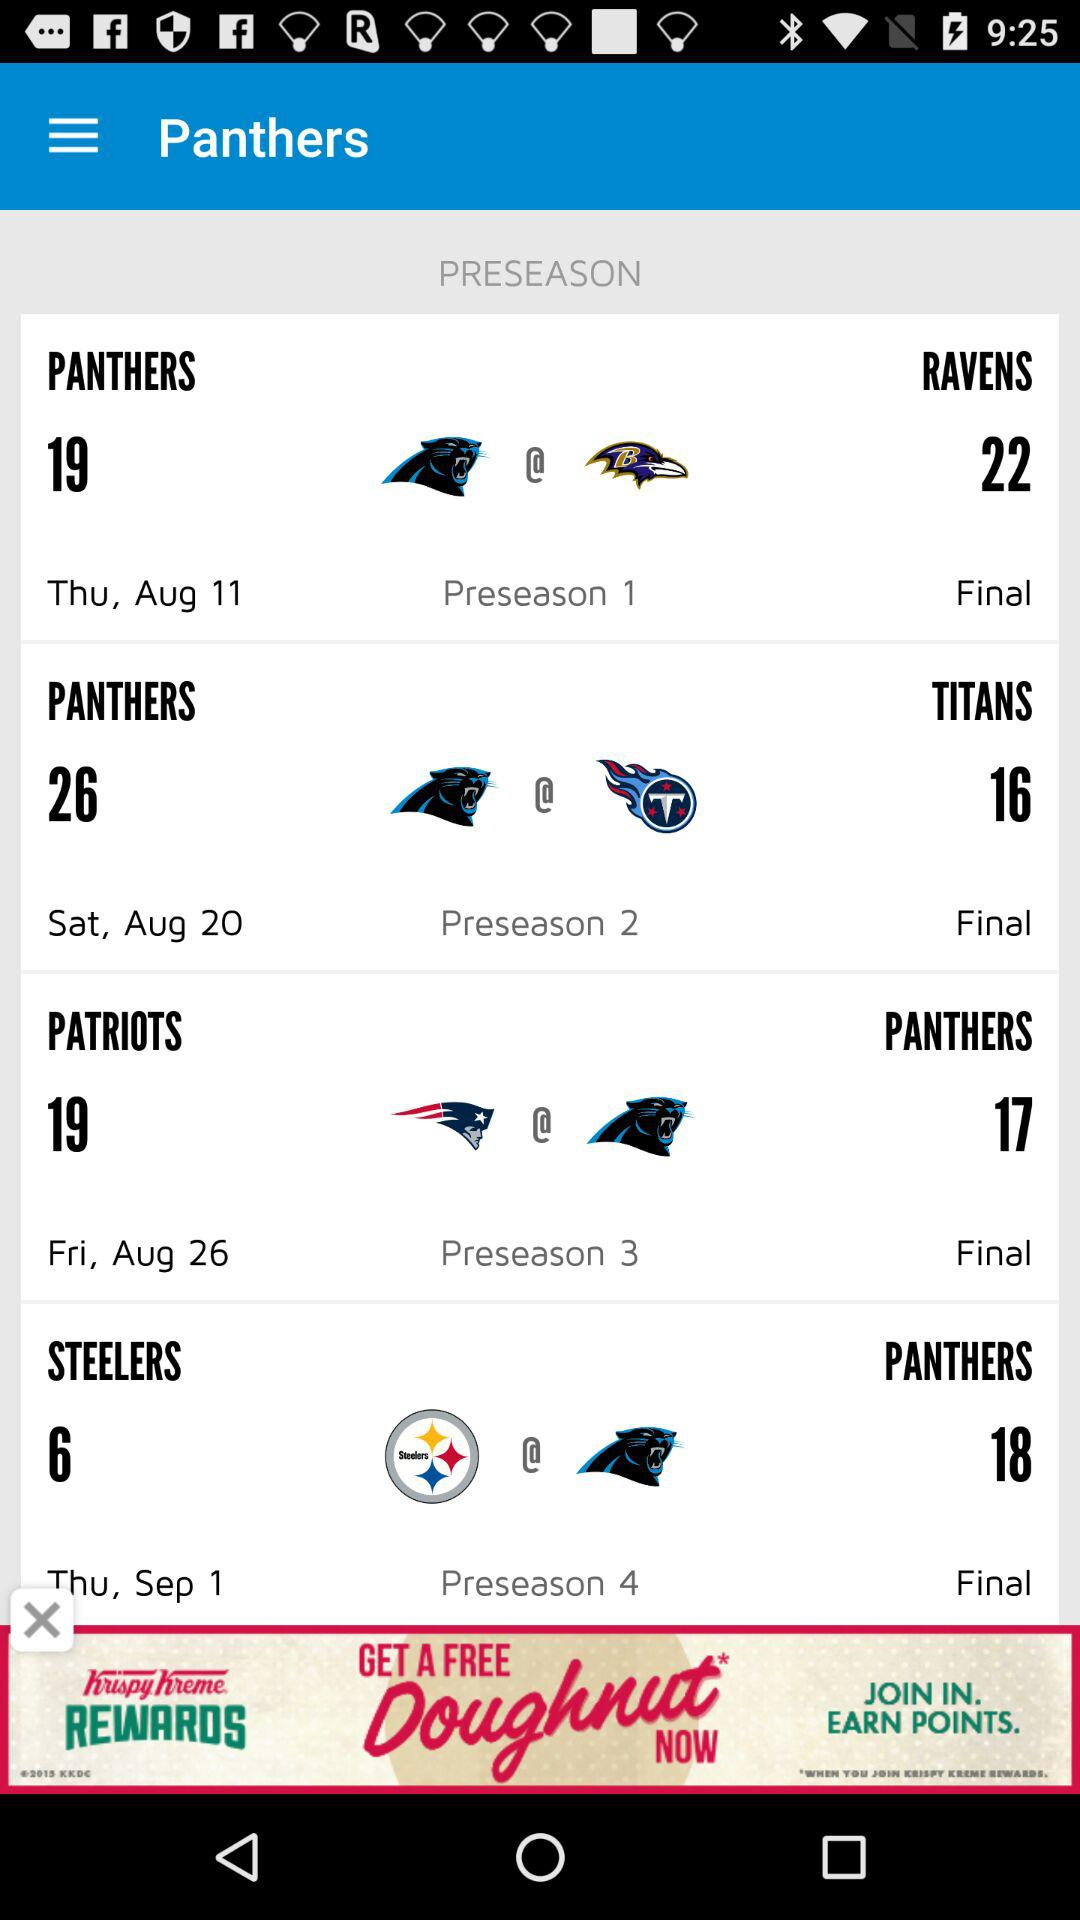How many games are in the preseason?
Answer the question using a single word or phrase. 4 